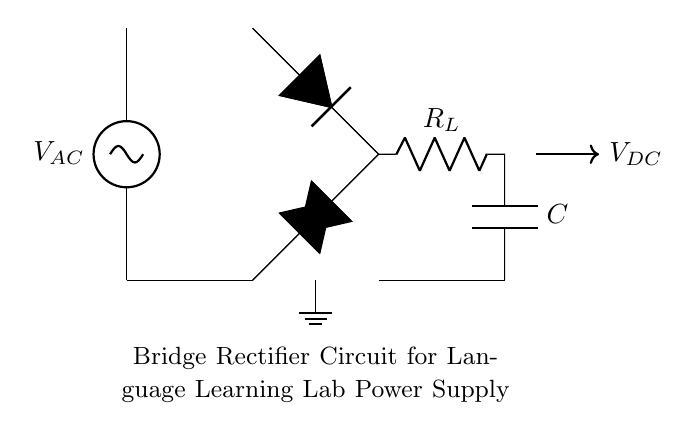What type of circuit is this? This is a bridge rectifier circuit, which is specifically designed to convert alternating current (AC) to direct current (DC). The arrangement of the diodes in a bridge format is crucial for this conversion process.
Answer: bridge rectifier What components are used in the circuit? The circuit comprises an alternating current source, four diodes, a load resistor, and a capacitor. These components work together to facilitate the conversion process from AC to DC.
Answer: AC source, diodes, load resistor, capacitor How many diodes are present in the circuit? There are four diodes in the bridge rectifier arrangement. They are arranged in a specific way to allow current to flow in both halves of the alternating input.
Answer: four What is the purpose of the capacitor in this circuit? The capacitor serves to smooth the output voltage, reducing fluctuations in the DC voltage after rectification. It stores charge and provides a more stable DC output.
Answer: smoothing output voltage What happens to the current direction during rectification? During rectification, the diodes allow current to flow in only one direction, effectively blocking the reverse current. This results in a pulsating DC output instead of an alternating current.
Answer: current flows only one direction What is the expected output voltage type from this circuit? The expected output voltage from the bridge rectifier circuit is direct current (DC). It follows the rectification process that has converted the input AC into a single-direction flow.
Answer: direct current What does the load resistor represent in this circuit? The load resistor represents the component that uses the DC power supplied by the rectifier. It is a key part of the circuit for testing and simulating the load in practical applications.
Answer: load for testing 